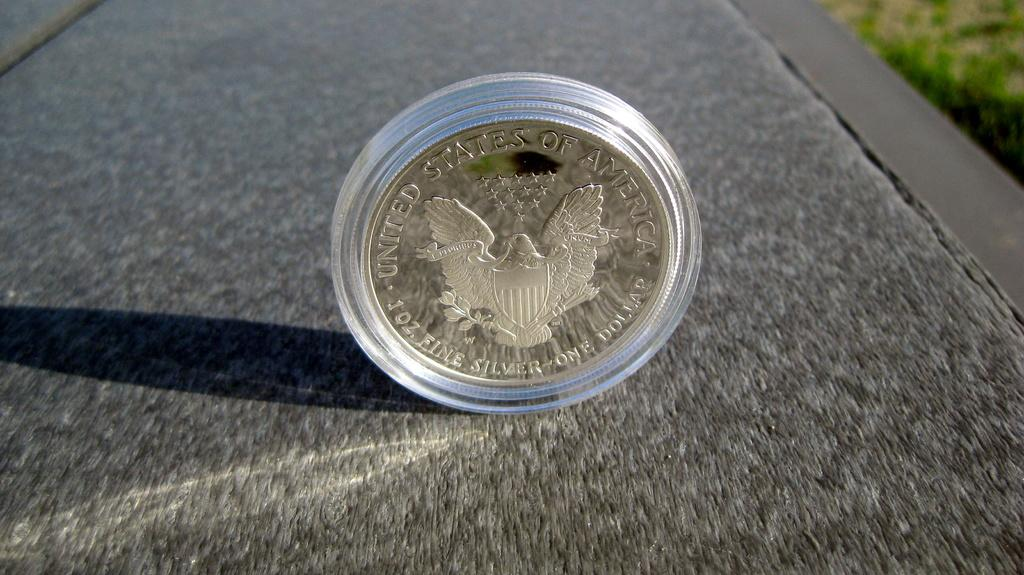What is on the floor in the image? There is a coin on the floor. What can be seen on the coin? The coin has text and an image on it. How would you describe the background of the image? The background of the image is blurred. How many people are in the group that is standing on the coin in the image? There is no group of people standing on the coin in the image; it is a single coin on the floor. 